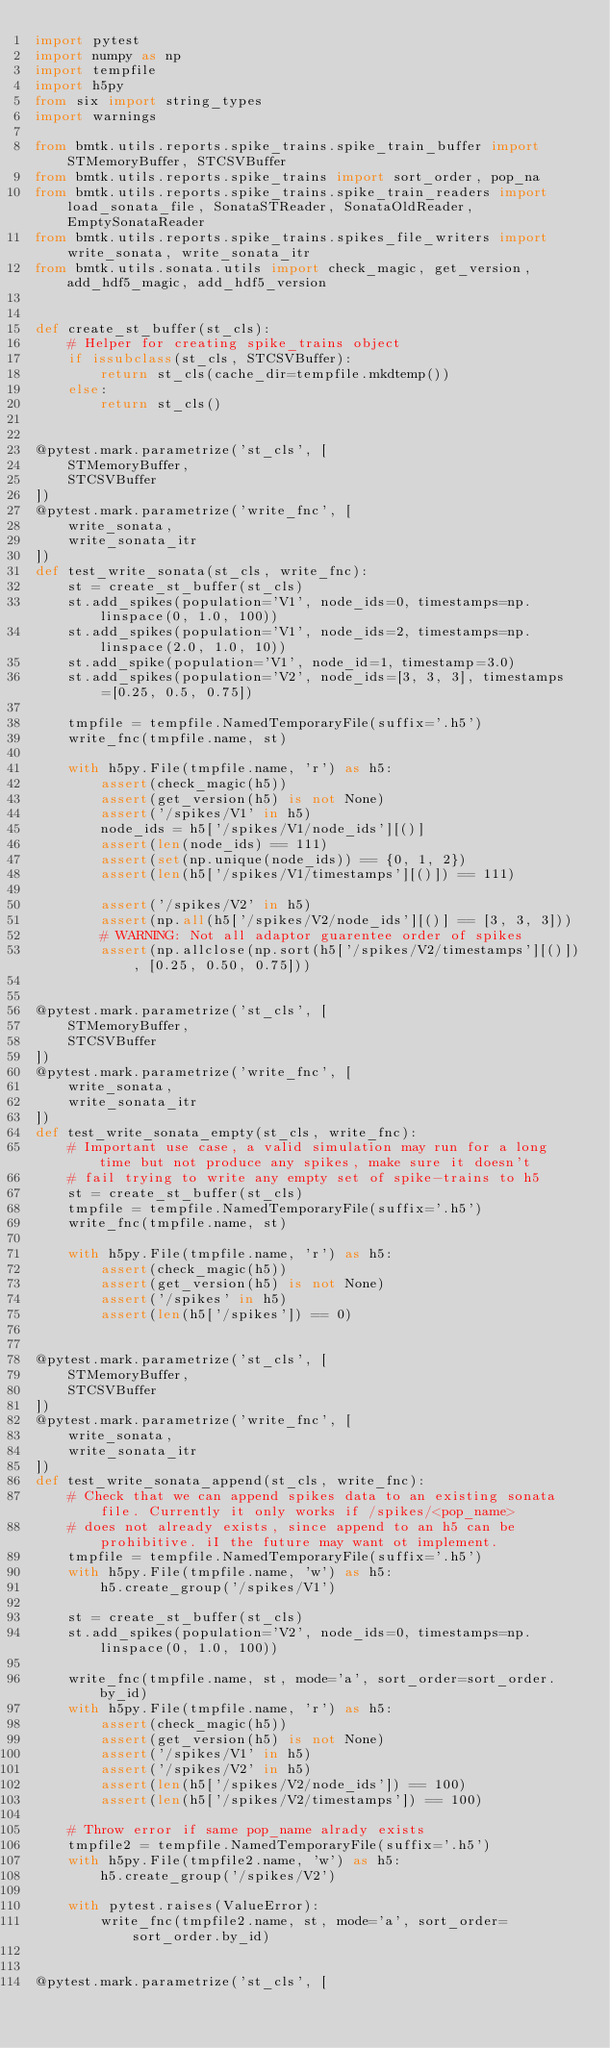Convert code to text. <code><loc_0><loc_0><loc_500><loc_500><_Python_>import pytest
import numpy as np
import tempfile
import h5py
from six import string_types
import warnings

from bmtk.utils.reports.spike_trains.spike_train_buffer import STMemoryBuffer, STCSVBuffer
from bmtk.utils.reports.spike_trains import sort_order, pop_na
from bmtk.utils.reports.spike_trains.spike_train_readers import load_sonata_file, SonataSTReader, SonataOldReader, EmptySonataReader
from bmtk.utils.reports.spike_trains.spikes_file_writers import write_sonata, write_sonata_itr
from bmtk.utils.sonata.utils import check_magic, get_version, add_hdf5_magic, add_hdf5_version


def create_st_buffer(st_cls):
    # Helper for creating spike_trains object
    if issubclass(st_cls, STCSVBuffer):
        return st_cls(cache_dir=tempfile.mkdtemp())
    else:
        return st_cls()


@pytest.mark.parametrize('st_cls', [
    STMemoryBuffer,
    STCSVBuffer
])
@pytest.mark.parametrize('write_fnc', [
    write_sonata,
    write_sonata_itr
])
def test_write_sonata(st_cls, write_fnc):
    st = create_st_buffer(st_cls)
    st.add_spikes(population='V1', node_ids=0, timestamps=np.linspace(0, 1.0, 100))
    st.add_spikes(population='V1', node_ids=2, timestamps=np.linspace(2.0, 1.0, 10))
    st.add_spike(population='V1', node_id=1, timestamp=3.0)
    st.add_spikes(population='V2', node_ids=[3, 3, 3], timestamps=[0.25, 0.5, 0.75])

    tmpfile = tempfile.NamedTemporaryFile(suffix='.h5')
    write_fnc(tmpfile.name, st)

    with h5py.File(tmpfile.name, 'r') as h5:
        assert(check_magic(h5))
        assert(get_version(h5) is not None)
        assert('/spikes/V1' in h5)
        node_ids = h5['/spikes/V1/node_ids'][()]
        assert(len(node_ids) == 111)
        assert(set(np.unique(node_ids)) == {0, 1, 2})
        assert(len(h5['/spikes/V1/timestamps'][()]) == 111)

        assert('/spikes/V2' in h5)
        assert(np.all(h5['/spikes/V2/node_ids'][()] == [3, 3, 3]))
        # WARNING: Not all adaptor guarentee order of spikes
        assert(np.allclose(np.sort(h5['/spikes/V2/timestamps'][()]), [0.25, 0.50, 0.75]))


@pytest.mark.parametrize('st_cls', [
    STMemoryBuffer,
    STCSVBuffer
])
@pytest.mark.parametrize('write_fnc', [
    write_sonata,
    write_sonata_itr
])
def test_write_sonata_empty(st_cls, write_fnc):
    # Important use case, a valid simulation may run for a long time but not produce any spikes, make sure it doesn't
    # fail trying to write any empty set of spike-trains to h5
    st = create_st_buffer(st_cls)
    tmpfile = tempfile.NamedTemporaryFile(suffix='.h5')
    write_fnc(tmpfile.name, st)

    with h5py.File(tmpfile.name, 'r') as h5:
        assert(check_magic(h5))
        assert(get_version(h5) is not None)
        assert('/spikes' in h5)
        assert(len(h5['/spikes']) == 0)


@pytest.mark.parametrize('st_cls', [
    STMemoryBuffer,
    STCSVBuffer
])
@pytest.mark.parametrize('write_fnc', [
    write_sonata,
    write_sonata_itr
])
def test_write_sonata_append(st_cls, write_fnc):
    # Check that we can append spikes data to an existing sonata file. Currently it only works if /spikes/<pop_name>
    # does not already exists, since append to an h5 can be prohibitive. iI the future may want ot implement.
    tmpfile = tempfile.NamedTemporaryFile(suffix='.h5')
    with h5py.File(tmpfile.name, 'w') as h5:
        h5.create_group('/spikes/V1')

    st = create_st_buffer(st_cls)
    st.add_spikes(population='V2', node_ids=0, timestamps=np.linspace(0, 1.0, 100))

    write_fnc(tmpfile.name, st, mode='a', sort_order=sort_order.by_id)
    with h5py.File(tmpfile.name, 'r') as h5:
        assert(check_magic(h5))
        assert(get_version(h5) is not None)
        assert('/spikes/V1' in h5)
        assert('/spikes/V2' in h5)
        assert(len(h5['/spikes/V2/node_ids']) == 100)
        assert(len(h5['/spikes/V2/timestamps']) == 100)

    # Throw error if same pop_name alrady exists
    tmpfile2 = tempfile.NamedTemporaryFile(suffix='.h5')
    with h5py.File(tmpfile2.name, 'w') as h5:
        h5.create_group('/spikes/V2')

    with pytest.raises(ValueError):
        write_fnc(tmpfile2.name, st, mode='a', sort_order=sort_order.by_id)


@pytest.mark.parametrize('st_cls', [</code> 